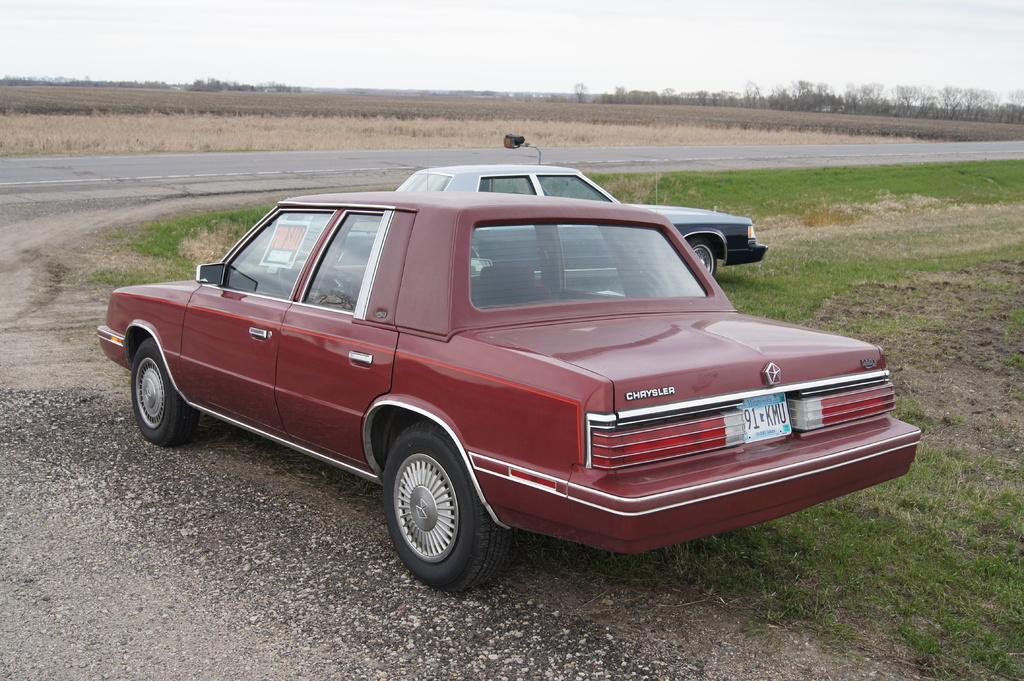What is blocking the path in the image? There is a car parked on the path in the image. What else can be seen in the background of the image? There is a vehicle, a road, trees, plants, and the sky visible in the background of the image. What year is the paper written in that is visible in the image? There is no paper present in the image, so it is not possible to determine the year it was written in. 